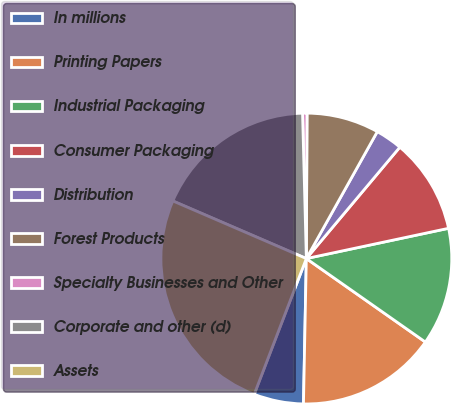<chart> <loc_0><loc_0><loc_500><loc_500><pie_chart><fcel>In millions<fcel>Printing Papers<fcel>Industrial Packaging<fcel>Consumer Packaging<fcel>Distribution<fcel>Forest Products<fcel>Specialty Businesses and Other<fcel>Corporate and other (d)<fcel>Assets<nl><fcel>5.52%<fcel>15.58%<fcel>13.07%<fcel>10.55%<fcel>3.0%<fcel>8.04%<fcel>0.49%<fcel>18.1%<fcel>25.65%<nl></chart> 